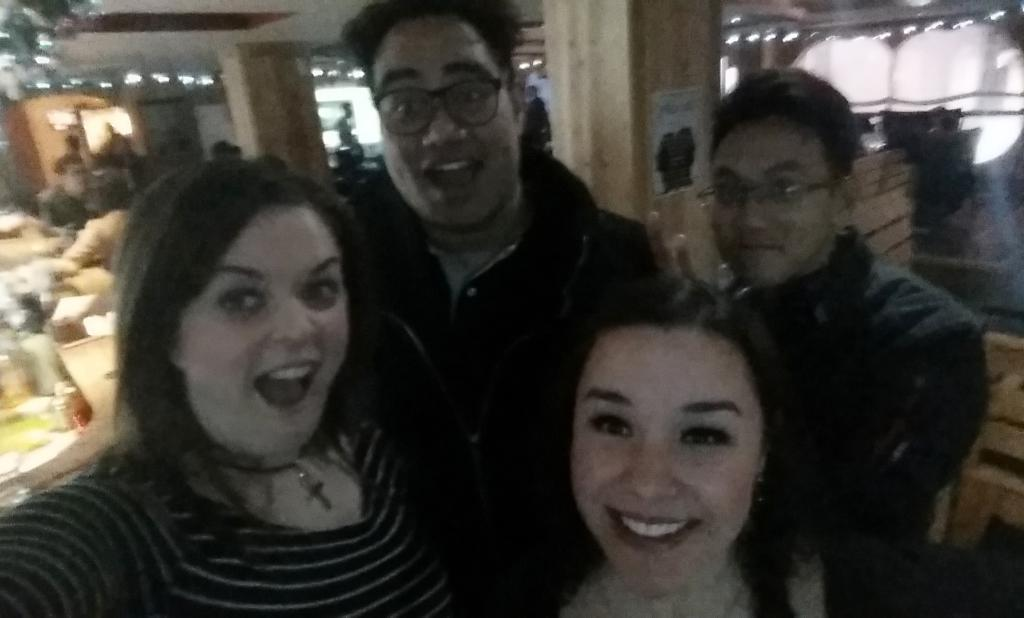What types of people are in the image? There are boys and girls in the image. Where are the children positioned in the image? The children are standing in the front. What is the facial expression of the children? The children are smiling. What are the children doing in the image? The children are posing for the camera. What can be seen in the background of the image? There is a restaurant view in the background, which includes tables and chairs. Can you see any veins in the children's arms in the image? There is no visible detail of the children's arms or veins in the image. What park can be seen in the background of the image? There is no park present in the image; it features a restaurant view in the background. 